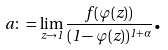Convert formula to latex. <formula><loc_0><loc_0><loc_500><loc_500>a \colon = \lim _ { z \rightarrow 1 } \frac { f ( \varphi ( z ) ) } { ( 1 - \varphi ( z ) ) ^ { 1 + \alpha } } \text {.}</formula> 